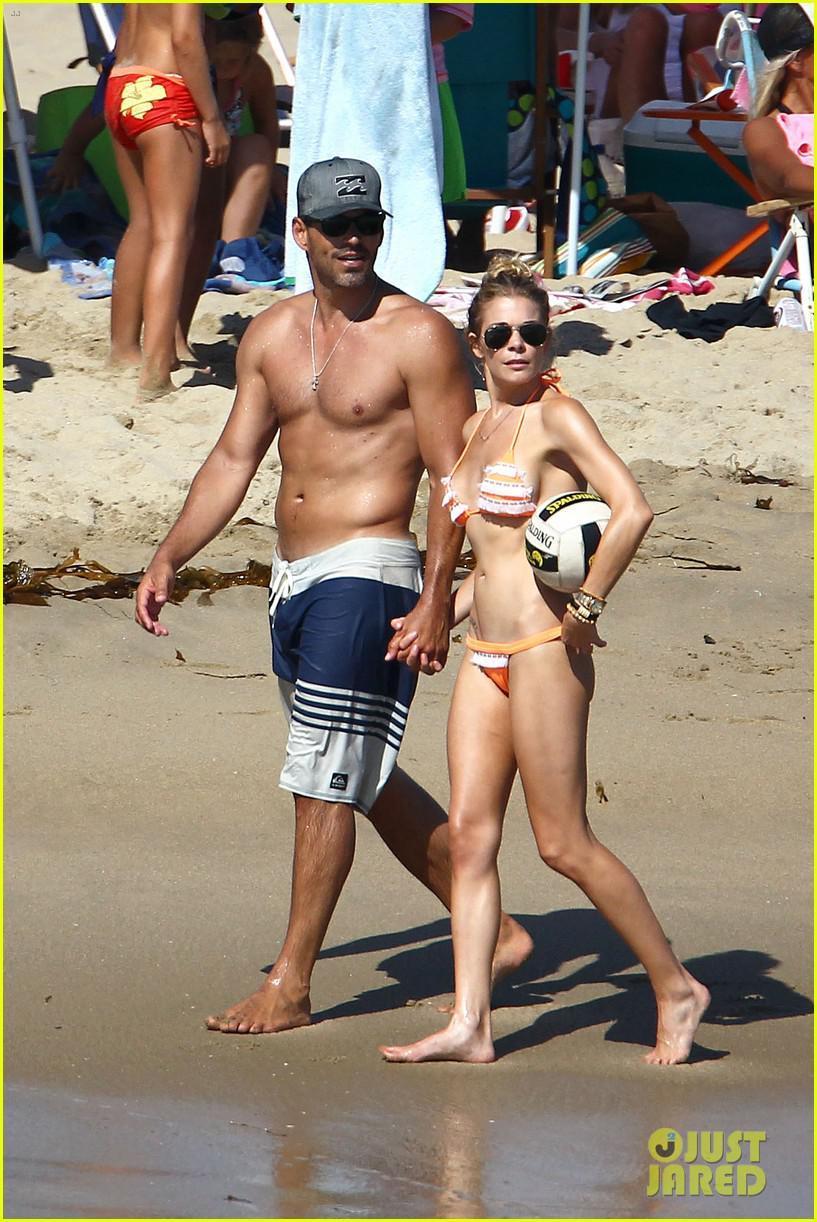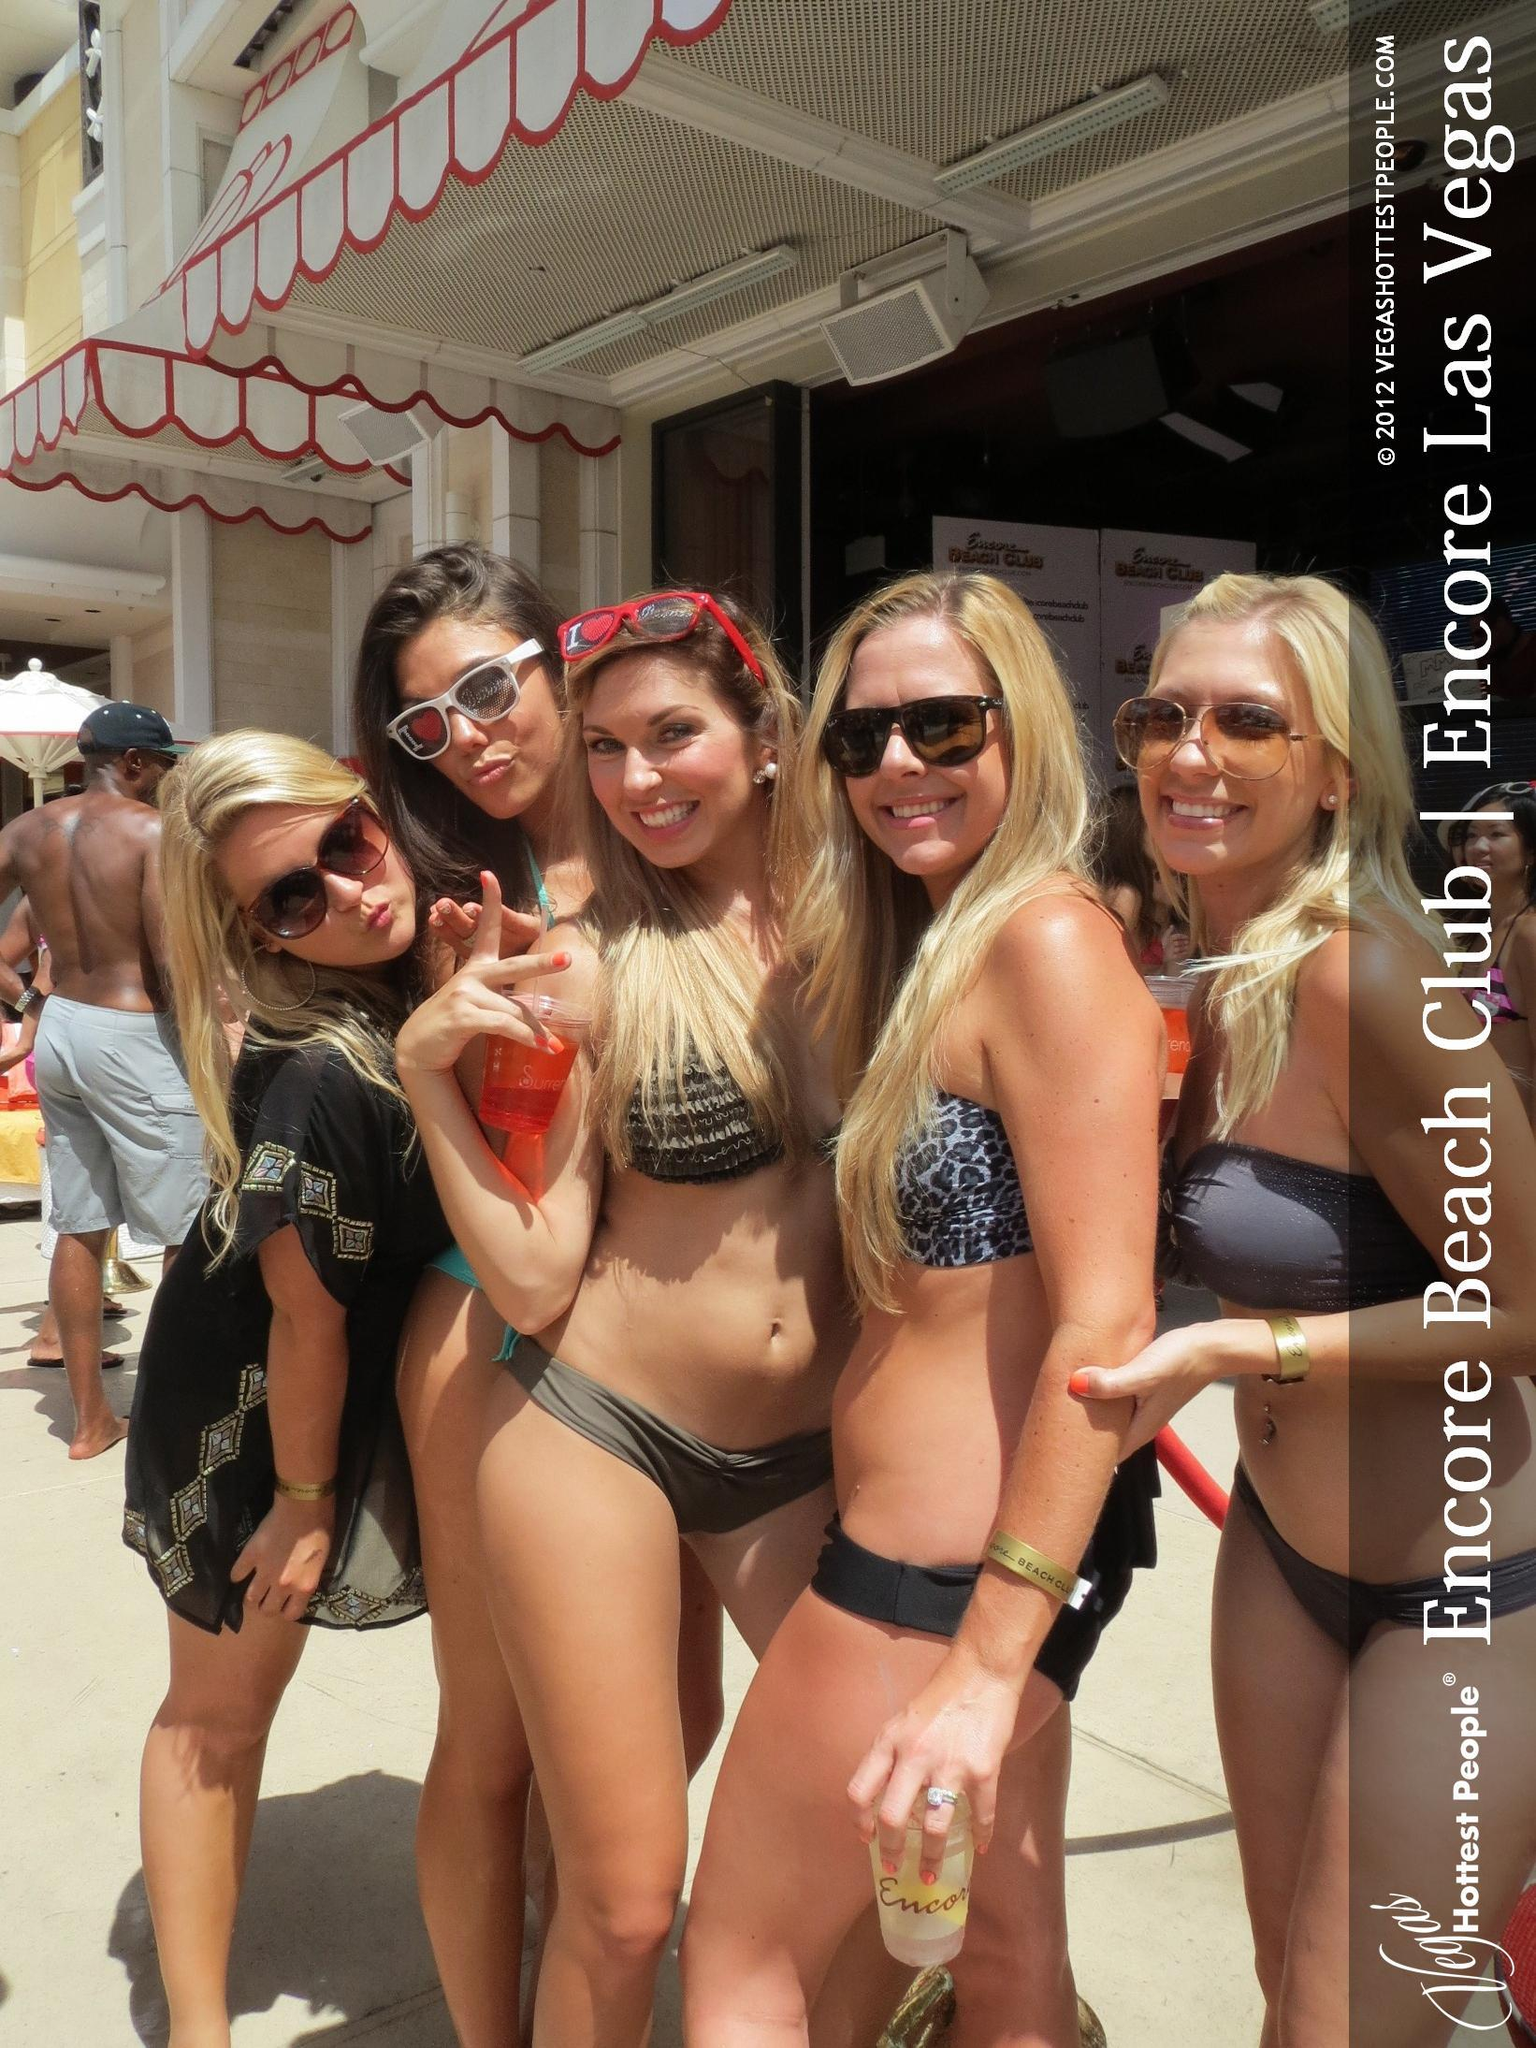The first image is the image on the left, the second image is the image on the right. For the images displayed, is the sentence "A woman is holding a phone." factually correct? Answer yes or no. No. 